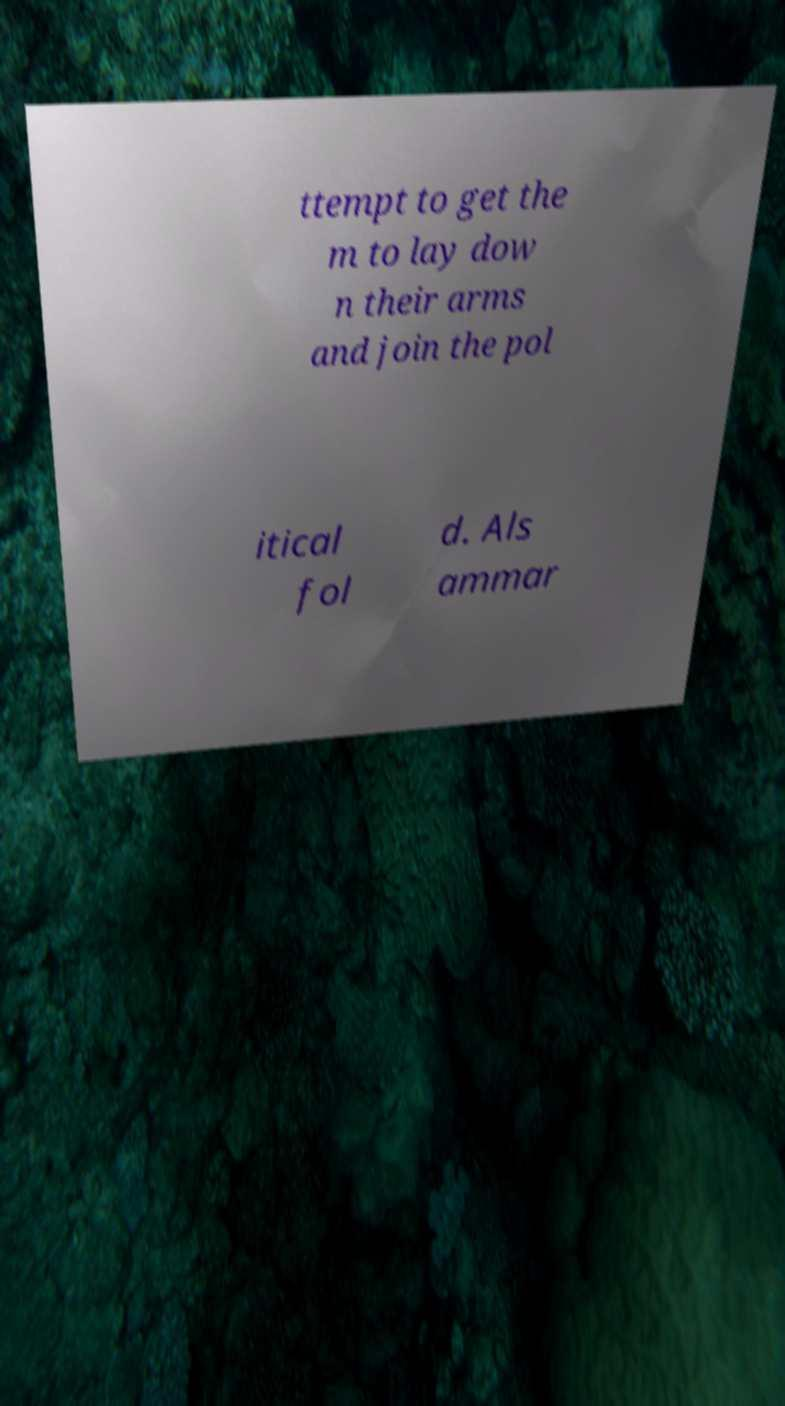There's text embedded in this image that I need extracted. Can you transcribe it verbatim? ttempt to get the m to lay dow n their arms and join the pol itical fol d. Als ammar 